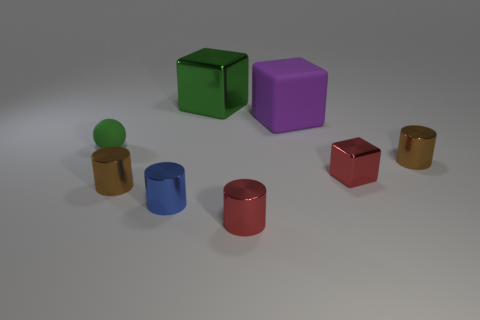Subtract all small blue shiny cylinders. How many cylinders are left? 3 Add 2 small cyan metal cylinders. How many objects exist? 10 Subtract all brown cylinders. How many cylinders are left? 2 Subtract all spheres. How many objects are left? 7 Subtract 2 blocks. How many blocks are left? 1 Add 6 tiny metal cylinders. How many tiny metal cylinders are left? 10 Add 1 tiny cubes. How many tiny cubes exist? 2 Subtract 1 green blocks. How many objects are left? 7 Subtract all purple blocks. Subtract all cyan cylinders. How many blocks are left? 2 Subtract all blue balls. How many gray cubes are left? 0 